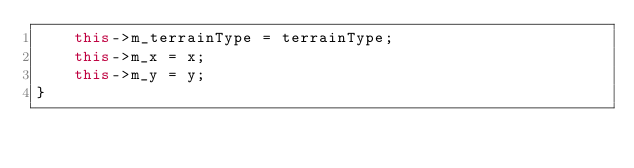Convert code to text. <code><loc_0><loc_0><loc_500><loc_500><_C++_>    this->m_terrainType = terrainType;
    this->m_x = x;
    this->m_y = y;
}
</code> 